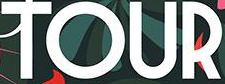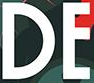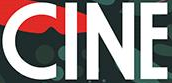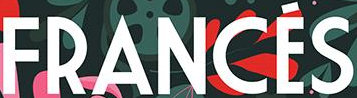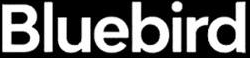Read the text from these images in sequence, separated by a semicolon. TOUR; DE; CINE; FRANCÉS; Bluebird 